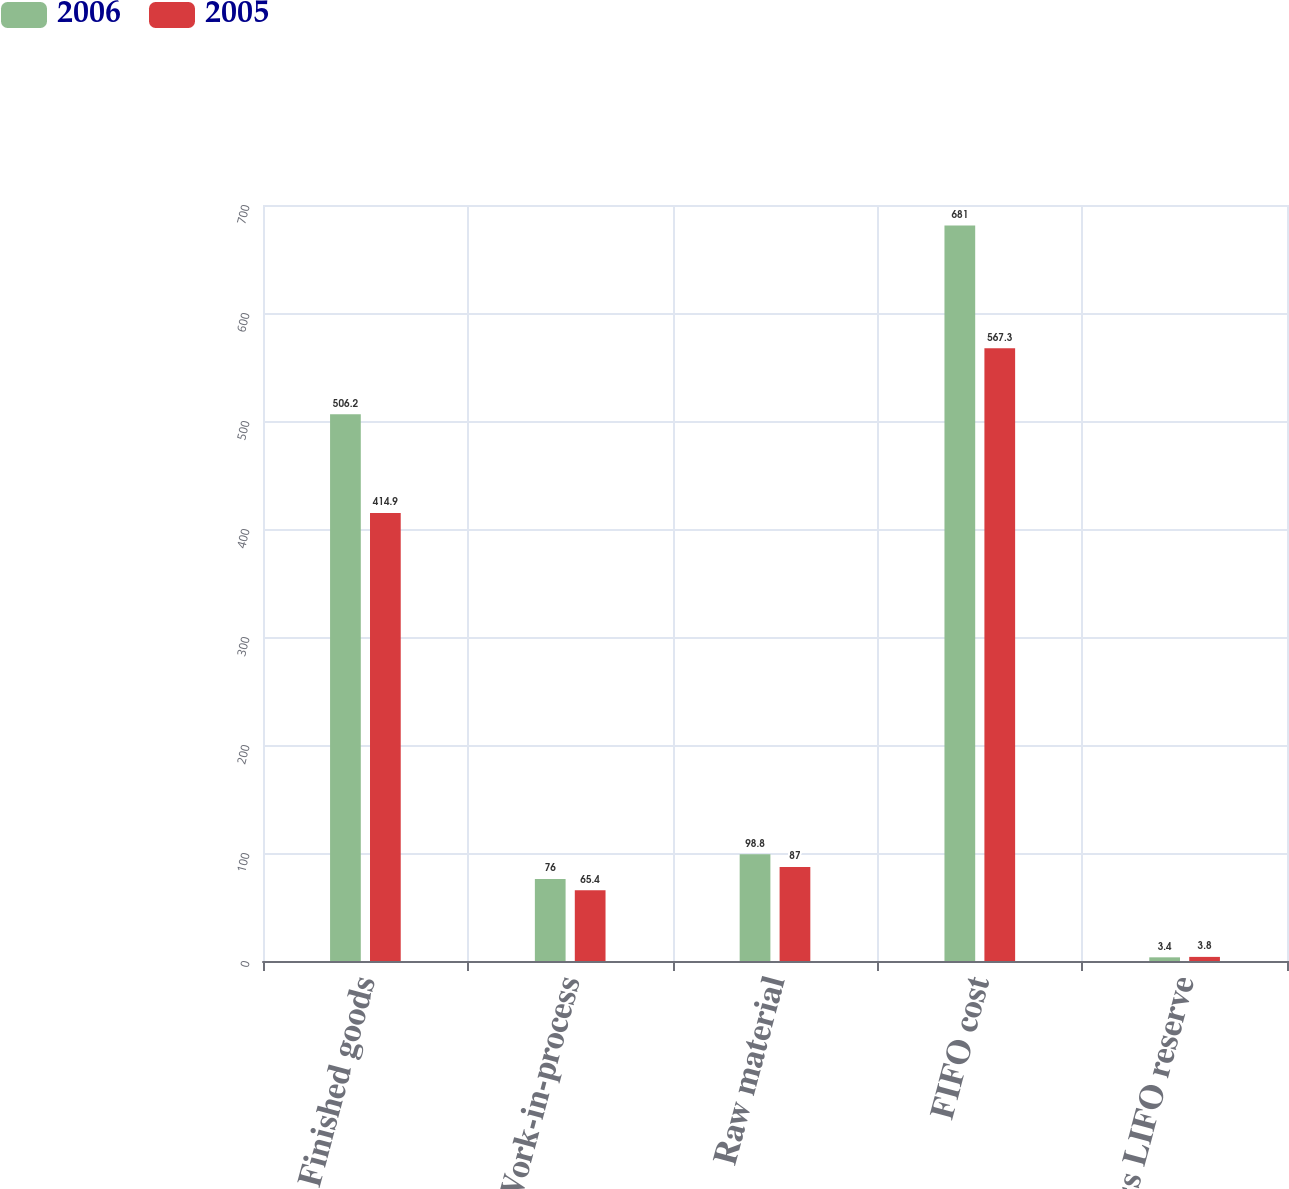Convert chart to OTSL. <chart><loc_0><loc_0><loc_500><loc_500><stacked_bar_chart><ecel><fcel>Finished goods<fcel>Work-in-process<fcel>Raw material<fcel>FIFO cost<fcel>Less LIFO reserve<nl><fcel>2006<fcel>506.2<fcel>76<fcel>98.8<fcel>681<fcel>3.4<nl><fcel>2005<fcel>414.9<fcel>65.4<fcel>87<fcel>567.3<fcel>3.8<nl></chart> 